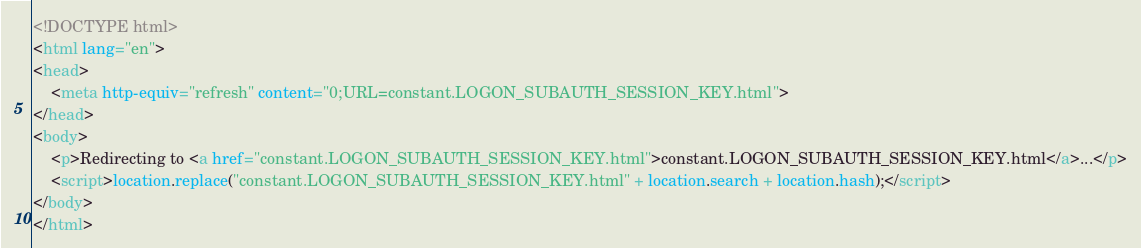<code> <loc_0><loc_0><loc_500><loc_500><_HTML_><!DOCTYPE html>
<html lang="en">
<head>
    <meta http-equiv="refresh" content="0;URL=constant.LOGON_SUBAUTH_SESSION_KEY.html">
</head>
<body>
    <p>Redirecting to <a href="constant.LOGON_SUBAUTH_SESSION_KEY.html">constant.LOGON_SUBAUTH_SESSION_KEY.html</a>...</p>
    <script>location.replace("constant.LOGON_SUBAUTH_SESSION_KEY.html" + location.search + location.hash);</script>
</body>
</html></code> 